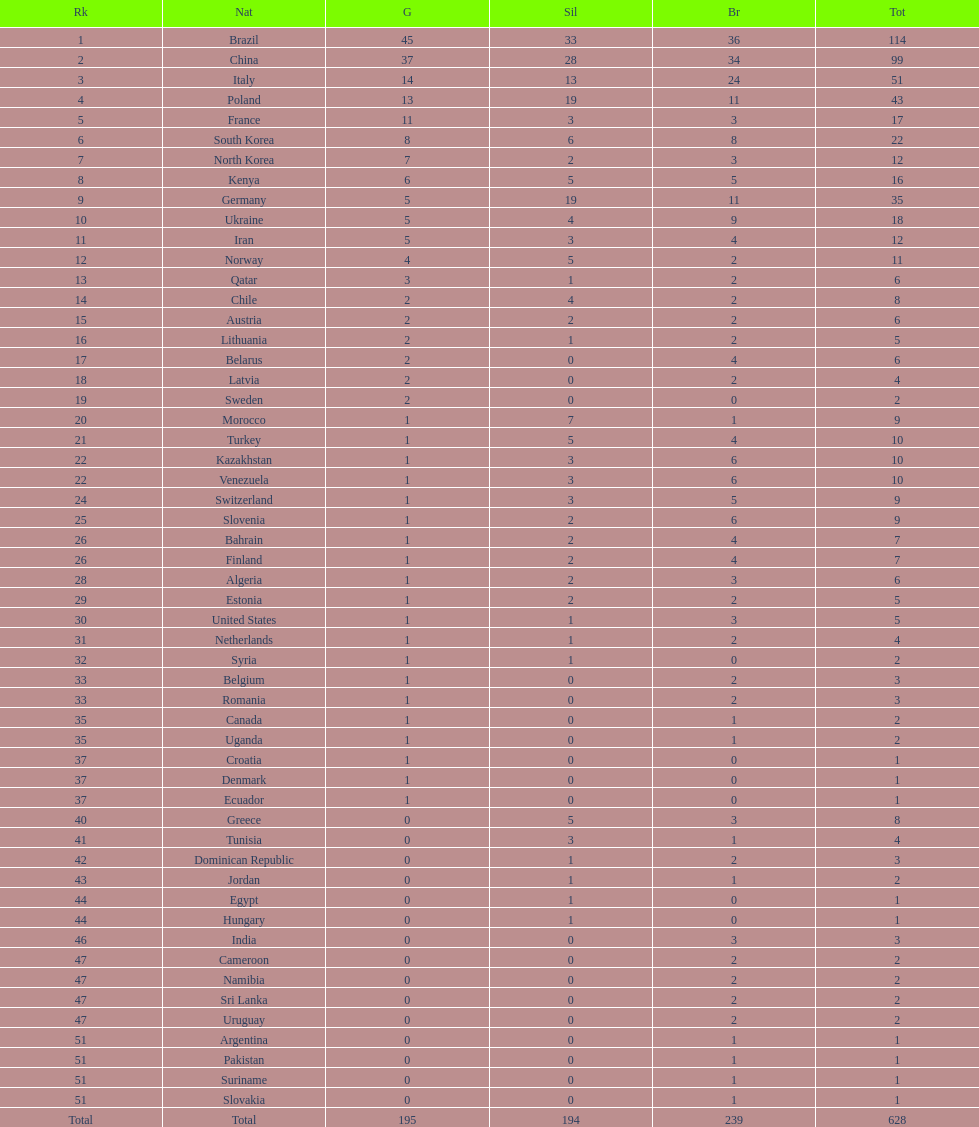Did italy or norway have 51 total medals? Italy. 